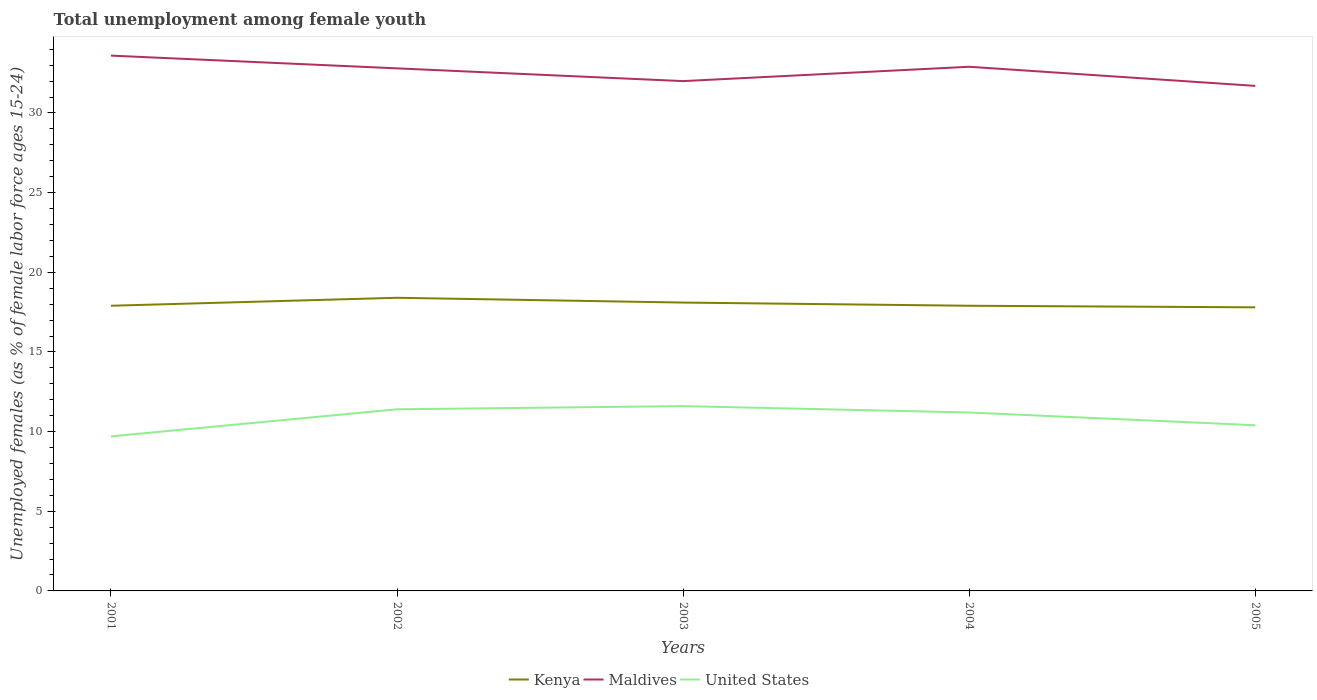Does the line corresponding to Kenya intersect with the line corresponding to United States?
Keep it short and to the point. No. Across all years, what is the maximum percentage of unemployed females in in United States?
Your answer should be very brief. 9.7. What is the total percentage of unemployed females in in Kenya in the graph?
Give a very brief answer. 0.1. What is the difference between the highest and the second highest percentage of unemployed females in in United States?
Make the answer very short. 1.9. Is the percentage of unemployed females in in Kenya strictly greater than the percentage of unemployed females in in Maldives over the years?
Ensure brevity in your answer.  Yes. How many years are there in the graph?
Keep it short and to the point. 5. Does the graph contain any zero values?
Give a very brief answer. No. Where does the legend appear in the graph?
Offer a terse response. Bottom center. How many legend labels are there?
Give a very brief answer. 3. What is the title of the graph?
Keep it short and to the point. Total unemployment among female youth. What is the label or title of the X-axis?
Give a very brief answer. Years. What is the label or title of the Y-axis?
Your answer should be compact. Unemployed females (as % of female labor force ages 15-24). What is the Unemployed females (as % of female labor force ages 15-24) of Kenya in 2001?
Keep it short and to the point. 17.9. What is the Unemployed females (as % of female labor force ages 15-24) in Maldives in 2001?
Give a very brief answer. 33.6. What is the Unemployed females (as % of female labor force ages 15-24) in United States in 2001?
Ensure brevity in your answer.  9.7. What is the Unemployed females (as % of female labor force ages 15-24) in Kenya in 2002?
Make the answer very short. 18.4. What is the Unemployed females (as % of female labor force ages 15-24) in Maldives in 2002?
Provide a short and direct response. 32.8. What is the Unemployed females (as % of female labor force ages 15-24) of United States in 2002?
Keep it short and to the point. 11.4. What is the Unemployed females (as % of female labor force ages 15-24) in Kenya in 2003?
Keep it short and to the point. 18.1. What is the Unemployed females (as % of female labor force ages 15-24) of Maldives in 2003?
Your answer should be very brief. 32. What is the Unemployed females (as % of female labor force ages 15-24) of United States in 2003?
Your answer should be very brief. 11.6. What is the Unemployed females (as % of female labor force ages 15-24) in Kenya in 2004?
Provide a succinct answer. 17.9. What is the Unemployed females (as % of female labor force ages 15-24) of Maldives in 2004?
Your response must be concise. 32.9. What is the Unemployed females (as % of female labor force ages 15-24) in United States in 2004?
Your answer should be very brief. 11.2. What is the Unemployed females (as % of female labor force ages 15-24) of Kenya in 2005?
Ensure brevity in your answer.  17.8. What is the Unemployed females (as % of female labor force ages 15-24) of Maldives in 2005?
Ensure brevity in your answer.  31.7. What is the Unemployed females (as % of female labor force ages 15-24) of United States in 2005?
Your answer should be compact. 10.4. Across all years, what is the maximum Unemployed females (as % of female labor force ages 15-24) in Kenya?
Offer a very short reply. 18.4. Across all years, what is the maximum Unemployed females (as % of female labor force ages 15-24) of Maldives?
Your answer should be very brief. 33.6. Across all years, what is the maximum Unemployed females (as % of female labor force ages 15-24) of United States?
Keep it short and to the point. 11.6. Across all years, what is the minimum Unemployed females (as % of female labor force ages 15-24) in Kenya?
Make the answer very short. 17.8. Across all years, what is the minimum Unemployed females (as % of female labor force ages 15-24) of Maldives?
Your answer should be compact. 31.7. Across all years, what is the minimum Unemployed females (as % of female labor force ages 15-24) of United States?
Ensure brevity in your answer.  9.7. What is the total Unemployed females (as % of female labor force ages 15-24) of Kenya in the graph?
Provide a succinct answer. 90.1. What is the total Unemployed females (as % of female labor force ages 15-24) of Maldives in the graph?
Your answer should be very brief. 163. What is the total Unemployed females (as % of female labor force ages 15-24) of United States in the graph?
Offer a very short reply. 54.3. What is the difference between the Unemployed females (as % of female labor force ages 15-24) in Maldives in 2001 and that in 2003?
Give a very brief answer. 1.6. What is the difference between the Unemployed females (as % of female labor force ages 15-24) of United States in 2001 and that in 2003?
Offer a very short reply. -1.9. What is the difference between the Unemployed females (as % of female labor force ages 15-24) in Kenya in 2001 and that in 2004?
Your answer should be compact. 0. What is the difference between the Unemployed females (as % of female labor force ages 15-24) in Kenya in 2001 and that in 2005?
Offer a very short reply. 0.1. What is the difference between the Unemployed females (as % of female labor force ages 15-24) in Maldives in 2001 and that in 2005?
Your answer should be very brief. 1.9. What is the difference between the Unemployed females (as % of female labor force ages 15-24) in Kenya in 2002 and that in 2004?
Provide a short and direct response. 0.5. What is the difference between the Unemployed females (as % of female labor force ages 15-24) in Maldives in 2002 and that in 2004?
Ensure brevity in your answer.  -0.1. What is the difference between the Unemployed females (as % of female labor force ages 15-24) in United States in 2002 and that in 2004?
Offer a terse response. 0.2. What is the difference between the Unemployed females (as % of female labor force ages 15-24) of Kenya in 2002 and that in 2005?
Offer a terse response. 0.6. What is the difference between the Unemployed females (as % of female labor force ages 15-24) of Maldives in 2002 and that in 2005?
Your response must be concise. 1.1. What is the difference between the Unemployed females (as % of female labor force ages 15-24) of Maldives in 2003 and that in 2004?
Your answer should be compact. -0.9. What is the difference between the Unemployed females (as % of female labor force ages 15-24) of Maldives in 2003 and that in 2005?
Offer a very short reply. 0.3. What is the difference between the Unemployed females (as % of female labor force ages 15-24) of United States in 2003 and that in 2005?
Offer a very short reply. 1.2. What is the difference between the Unemployed females (as % of female labor force ages 15-24) in Kenya in 2001 and the Unemployed females (as % of female labor force ages 15-24) in Maldives in 2002?
Provide a short and direct response. -14.9. What is the difference between the Unemployed females (as % of female labor force ages 15-24) of Kenya in 2001 and the Unemployed females (as % of female labor force ages 15-24) of Maldives in 2003?
Your answer should be very brief. -14.1. What is the difference between the Unemployed females (as % of female labor force ages 15-24) of Maldives in 2001 and the Unemployed females (as % of female labor force ages 15-24) of United States in 2004?
Ensure brevity in your answer.  22.4. What is the difference between the Unemployed females (as % of female labor force ages 15-24) of Maldives in 2001 and the Unemployed females (as % of female labor force ages 15-24) of United States in 2005?
Keep it short and to the point. 23.2. What is the difference between the Unemployed females (as % of female labor force ages 15-24) of Kenya in 2002 and the Unemployed females (as % of female labor force ages 15-24) of United States in 2003?
Ensure brevity in your answer.  6.8. What is the difference between the Unemployed females (as % of female labor force ages 15-24) in Maldives in 2002 and the Unemployed females (as % of female labor force ages 15-24) in United States in 2003?
Offer a terse response. 21.2. What is the difference between the Unemployed females (as % of female labor force ages 15-24) of Kenya in 2002 and the Unemployed females (as % of female labor force ages 15-24) of United States in 2004?
Offer a terse response. 7.2. What is the difference between the Unemployed females (as % of female labor force ages 15-24) of Maldives in 2002 and the Unemployed females (as % of female labor force ages 15-24) of United States in 2004?
Your answer should be compact. 21.6. What is the difference between the Unemployed females (as % of female labor force ages 15-24) of Kenya in 2002 and the Unemployed females (as % of female labor force ages 15-24) of Maldives in 2005?
Offer a very short reply. -13.3. What is the difference between the Unemployed females (as % of female labor force ages 15-24) of Maldives in 2002 and the Unemployed females (as % of female labor force ages 15-24) of United States in 2005?
Make the answer very short. 22.4. What is the difference between the Unemployed females (as % of female labor force ages 15-24) of Kenya in 2003 and the Unemployed females (as % of female labor force ages 15-24) of Maldives in 2004?
Keep it short and to the point. -14.8. What is the difference between the Unemployed females (as % of female labor force ages 15-24) of Kenya in 2003 and the Unemployed females (as % of female labor force ages 15-24) of United States in 2004?
Keep it short and to the point. 6.9. What is the difference between the Unemployed females (as % of female labor force ages 15-24) in Maldives in 2003 and the Unemployed females (as % of female labor force ages 15-24) in United States in 2004?
Provide a succinct answer. 20.8. What is the difference between the Unemployed females (as % of female labor force ages 15-24) of Maldives in 2003 and the Unemployed females (as % of female labor force ages 15-24) of United States in 2005?
Provide a short and direct response. 21.6. What is the difference between the Unemployed females (as % of female labor force ages 15-24) of Kenya in 2004 and the Unemployed females (as % of female labor force ages 15-24) of United States in 2005?
Your answer should be compact. 7.5. What is the difference between the Unemployed females (as % of female labor force ages 15-24) in Maldives in 2004 and the Unemployed females (as % of female labor force ages 15-24) in United States in 2005?
Provide a short and direct response. 22.5. What is the average Unemployed females (as % of female labor force ages 15-24) of Kenya per year?
Offer a terse response. 18.02. What is the average Unemployed females (as % of female labor force ages 15-24) of Maldives per year?
Provide a succinct answer. 32.6. What is the average Unemployed females (as % of female labor force ages 15-24) in United States per year?
Your answer should be compact. 10.86. In the year 2001, what is the difference between the Unemployed females (as % of female labor force ages 15-24) in Kenya and Unemployed females (as % of female labor force ages 15-24) in Maldives?
Ensure brevity in your answer.  -15.7. In the year 2001, what is the difference between the Unemployed females (as % of female labor force ages 15-24) in Kenya and Unemployed females (as % of female labor force ages 15-24) in United States?
Offer a very short reply. 8.2. In the year 2001, what is the difference between the Unemployed females (as % of female labor force ages 15-24) of Maldives and Unemployed females (as % of female labor force ages 15-24) of United States?
Provide a short and direct response. 23.9. In the year 2002, what is the difference between the Unemployed females (as % of female labor force ages 15-24) of Kenya and Unemployed females (as % of female labor force ages 15-24) of Maldives?
Give a very brief answer. -14.4. In the year 2002, what is the difference between the Unemployed females (as % of female labor force ages 15-24) of Maldives and Unemployed females (as % of female labor force ages 15-24) of United States?
Offer a terse response. 21.4. In the year 2003, what is the difference between the Unemployed females (as % of female labor force ages 15-24) in Kenya and Unemployed females (as % of female labor force ages 15-24) in United States?
Give a very brief answer. 6.5. In the year 2003, what is the difference between the Unemployed females (as % of female labor force ages 15-24) in Maldives and Unemployed females (as % of female labor force ages 15-24) in United States?
Offer a terse response. 20.4. In the year 2004, what is the difference between the Unemployed females (as % of female labor force ages 15-24) of Maldives and Unemployed females (as % of female labor force ages 15-24) of United States?
Ensure brevity in your answer.  21.7. In the year 2005, what is the difference between the Unemployed females (as % of female labor force ages 15-24) of Kenya and Unemployed females (as % of female labor force ages 15-24) of Maldives?
Give a very brief answer. -13.9. In the year 2005, what is the difference between the Unemployed females (as % of female labor force ages 15-24) in Maldives and Unemployed females (as % of female labor force ages 15-24) in United States?
Give a very brief answer. 21.3. What is the ratio of the Unemployed females (as % of female labor force ages 15-24) of Kenya in 2001 to that in 2002?
Your answer should be very brief. 0.97. What is the ratio of the Unemployed females (as % of female labor force ages 15-24) in Maldives in 2001 to that in 2002?
Make the answer very short. 1.02. What is the ratio of the Unemployed females (as % of female labor force ages 15-24) of United States in 2001 to that in 2002?
Ensure brevity in your answer.  0.85. What is the ratio of the Unemployed females (as % of female labor force ages 15-24) of United States in 2001 to that in 2003?
Your response must be concise. 0.84. What is the ratio of the Unemployed females (as % of female labor force ages 15-24) of Maldives in 2001 to that in 2004?
Keep it short and to the point. 1.02. What is the ratio of the Unemployed females (as % of female labor force ages 15-24) in United States in 2001 to that in 2004?
Make the answer very short. 0.87. What is the ratio of the Unemployed females (as % of female labor force ages 15-24) in Kenya in 2001 to that in 2005?
Your answer should be compact. 1.01. What is the ratio of the Unemployed females (as % of female labor force ages 15-24) of Maldives in 2001 to that in 2005?
Give a very brief answer. 1.06. What is the ratio of the Unemployed females (as % of female labor force ages 15-24) in United States in 2001 to that in 2005?
Give a very brief answer. 0.93. What is the ratio of the Unemployed females (as % of female labor force ages 15-24) of Kenya in 2002 to that in 2003?
Give a very brief answer. 1.02. What is the ratio of the Unemployed females (as % of female labor force ages 15-24) of United States in 2002 to that in 2003?
Make the answer very short. 0.98. What is the ratio of the Unemployed females (as % of female labor force ages 15-24) of Kenya in 2002 to that in 2004?
Your response must be concise. 1.03. What is the ratio of the Unemployed females (as % of female labor force ages 15-24) in United States in 2002 to that in 2004?
Offer a terse response. 1.02. What is the ratio of the Unemployed females (as % of female labor force ages 15-24) in Kenya in 2002 to that in 2005?
Provide a succinct answer. 1.03. What is the ratio of the Unemployed females (as % of female labor force ages 15-24) in Maldives in 2002 to that in 2005?
Make the answer very short. 1.03. What is the ratio of the Unemployed females (as % of female labor force ages 15-24) in United States in 2002 to that in 2005?
Give a very brief answer. 1.1. What is the ratio of the Unemployed females (as % of female labor force ages 15-24) in Kenya in 2003 to that in 2004?
Your answer should be very brief. 1.01. What is the ratio of the Unemployed females (as % of female labor force ages 15-24) in Maldives in 2003 to that in 2004?
Provide a succinct answer. 0.97. What is the ratio of the Unemployed females (as % of female labor force ages 15-24) in United States in 2003 to that in 2004?
Ensure brevity in your answer.  1.04. What is the ratio of the Unemployed females (as % of female labor force ages 15-24) in Kenya in 2003 to that in 2005?
Offer a very short reply. 1.02. What is the ratio of the Unemployed females (as % of female labor force ages 15-24) of Maldives in 2003 to that in 2005?
Offer a terse response. 1.01. What is the ratio of the Unemployed females (as % of female labor force ages 15-24) in United States in 2003 to that in 2005?
Make the answer very short. 1.12. What is the ratio of the Unemployed females (as % of female labor force ages 15-24) in Kenya in 2004 to that in 2005?
Your answer should be compact. 1.01. What is the ratio of the Unemployed females (as % of female labor force ages 15-24) in Maldives in 2004 to that in 2005?
Your answer should be very brief. 1.04. What is the difference between the highest and the second highest Unemployed females (as % of female labor force ages 15-24) in Kenya?
Give a very brief answer. 0.3. What is the difference between the highest and the second highest Unemployed females (as % of female labor force ages 15-24) in Maldives?
Make the answer very short. 0.7. What is the difference between the highest and the lowest Unemployed females (as % of female labor force ages 15-24) in Kenya?
Your answer should be compact. 0.6. What is the difference between the highest and the lowest Unemployed females (as % of female labor force ages 15-24) in Maldives?
Your answer should be compact. 1.9. 